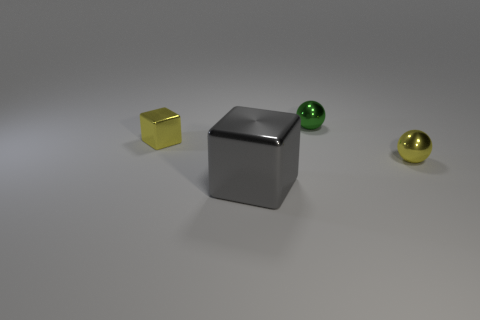There is a yellow thing that is in front of the small yellow cube; does it have the same shape as the green metal thing?
Your answer should be compact. Yes. What number of matte objects are either tiny green objects or purple cylinders?
Give a very brief answer. 0. Are there any big green blocks made of the same material as the small yellow sphere?
Offer a very short reply. No. The tiny yellow object that is to the left of the big thing right of the yellow object to the left of the small green metal ball is what shape?
Provide a short and direct response. Cube. Is the number of cubes that are behind the large metal block greater than the number of cyan metal objects?
Your answer should be compact. Yes. Is the shape of the big object the same as the yellow object that is left of the big gray thing?
Give a very brief answer. Yes. What shape is the tiny metallic object that is the same color as the small metallic block?
Give a very brief answer. Sphere. There is a metal ball that is in front of the tiny metallic ball to the left of the small yellow ball; how many tiny metal cubes are in front of it?
Offer a terse response. 0. What color is the other ball that is the same size as the yellow metallic ball?
Your response must be concise. Green. What size is the yellow thing in front of the thing left of the big gray block?
Keep it short and to the point. Small. 